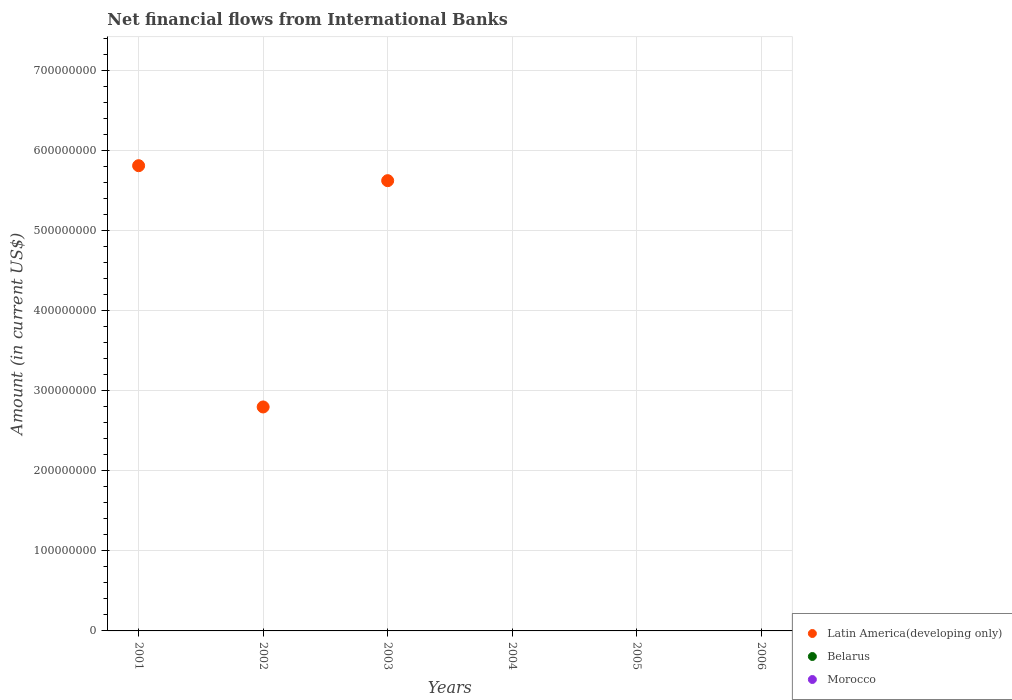Is the number of dotlines equal to the number of legend labels?
Offer a very short reply. No. Across all years, what is the maximum net financial aid flows in Latin America(developing only)?
Your answer should be very brief. 5.81e+08. In which year was the net financial aid flows in Latin America(developing only) maximum?
Your answer should be compact. 2001. What is the total net financial aid flows in Belarus in the graph?
Provide a succinct answer. 0. What is the difference between the net financial aid flows in Belarus in 2004 and the net financial aid flows in Morocco in 2002?
Keep it short and to the point. 0. What is the average net financial aid flows in Morocco per year?
Keep it short and to the point. 0. What is the difference between the highest and the second highest net financial aid flows in Latin America(developing only)?
Keep it short and to the point. 1.87e+07. What is the difference between the highest and the lowest net financial aid flows in Latin America(developing only)?
Offer a very short reply. 5.81e+08. In how many years, is the net financial aid flows in Morocco greater than the average net financial aid flows in Morocco taken over all years?
Offer a very short reply. 0. Is the sum of the net financial aid flows in Latin America(developing only) in 2002 and 2003 greater than the maximum net financial aid flows in Morocco across all years?
Your answer should be compact. Yes. Does the net financial aid flows in Morocco monotonically increase over the years?
Your response must be concise. No. Is the net financial aid flows in Belarus strictly greater than the net financial aid flows in Latin America(developing only) over the years?
Offer a terse response. No. Is the net financial aid flows in Latin America(developing only) strictly less than the net financial aid flows in Belarus over the years?
Keep it short and to the point. No. How many dotlines are there?
Give a very brief answer. 1. How many years are there in the graph?
Provide a short and direct response. 6. Are the values on the major ticks of Y-axis written in scientific E-notation?
Keep it short and to the point. No. Does the graph contain any zero values?
Offer a very short reply. Yes. Where does the legend appear in the graph?
Make the answer very short. Bottom right. How many legend labels are there?
Ensure brevity in your answer.  3. What is the title of the graph?
Your answer should be very brief. Net financial flows from International Banks. What is the label or title of the Y-axis?
Provide a succinct answer. Amount (in current US$). What is the Amount (in current US$) in Latin America(developing only) in 2001?
Make the answer very short. 5.81e+08. What is the Amount (in current US$) of Morocco in 2001?
Your answer should be compact. 0. What is the Amount (in current US$) of Latin America(developing only) in 2002?
Your response must be concise. 2.80e+08. What is the Amount (in current US$) of Latin America(developing only) in 2003?
Your response must be concise. 5.62e+08. What is the Amount (in current US$) of Belarus in 2003?
Give a very brief answer. 0. What is the Amount (in current US$) of Morocco in 2003?
Offer a terse response. 0. What is the Amount (in current US$) of Latin America(developing only) in 2004?
Offer a terse response. 0. What is the Amount (in current US$) in Belarus in 2005?
Make the answer very short. 0. What is the Amount (in current US$) of Morocco in 2005?
Make the answer very short. 0. What is the Amount (in current US$) of Belarus in 2006?
Offer a very short reply. 0. Across all years, what is the maximum Amount (in current US$) in Latin America(developing only)?
Provide a succinct answer. 5.81e+08. Across all years, what is the minimum Amount (in current US$) of Latin America(developing only)?
Ensure brevity in your answer.  0. What is the total Amount (in current US$) in Latin America(developing only) in the graph?
Provide a succinct answer. 1.42e+09. What is the difference between the Amount (in current US$) of Latin America(developing only) in 2001 and that in 2002?
Offer a terse response. 3.01e+08. What is the difference between the Amount (in current US$) in Latin America(developing only) in 2001 and that in 2003?
Offer a very short reply. 1.87e+07. What is the difference between the Amount (in current US$) of Latin America(developing only) in 2002 and that in 2003?
Your answer should be compact. -2.82e+08. What is the average Amount (in current US$) in Latin America(developing only) per year?
Your answer should be compact. 2.37e+08. What is the average Amount (in current US$) in Morocco per year?
Provide a succinct answer. 0. What is the ratio of the Amount (in current US$) of Latin America(developing only) in 2001 to that in 2002?
Your answer should be very brief. 2.08. What is the ratio of the Amount (in current US$) in Latin America(developing only) in 2002 to that in 2003?
Your answer should be very brief. 0.5. What is the difference between the highest and the second highest Amount (in current US$) of Latin America(developing only)?
Your answer should be very brief. 1.87e+07. What is the difference between the highest and the lowest Amount (in current US$) of Latin America(developing only)?
Offer a terse response. 5.81e+08. 